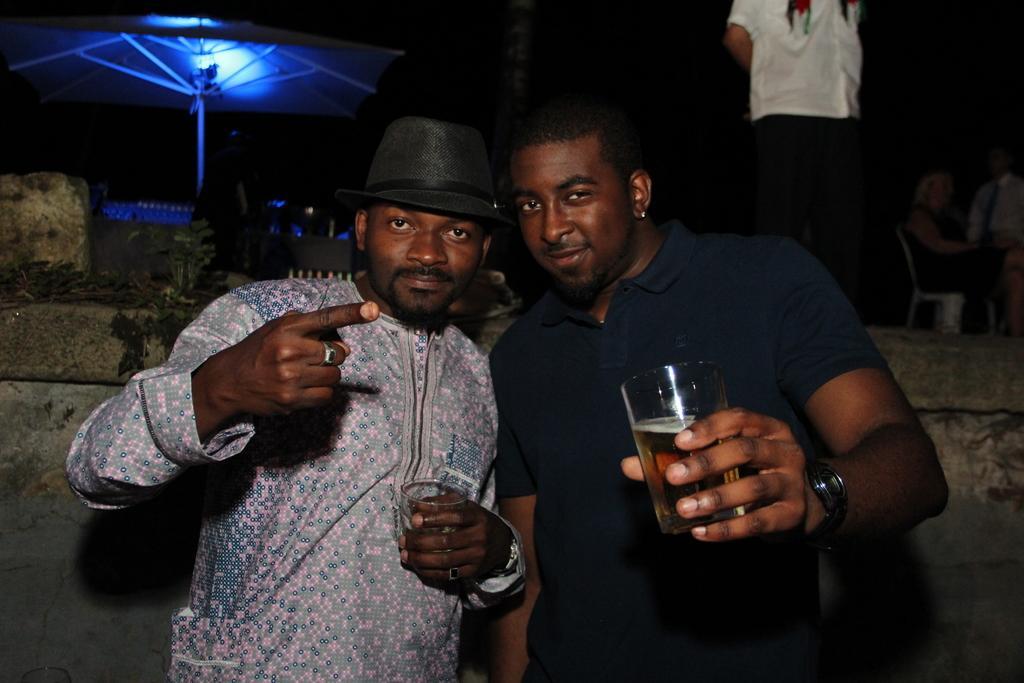Can you describe this image briefly? In front of the image there are two people holding the glass in their hands. Behind them there is a wall. There is a person standing. There are a few people sitting on the chairs. There is a tent. In the background of the image there is a building. 